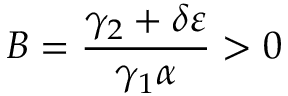<formula> <loc_0><loc_0><loc_500><loc_500>B = \frac { \gamma _ { 2 } + \delta \varepsilon } { \gamma _ { 1 } \alpha } > 0</formula> 